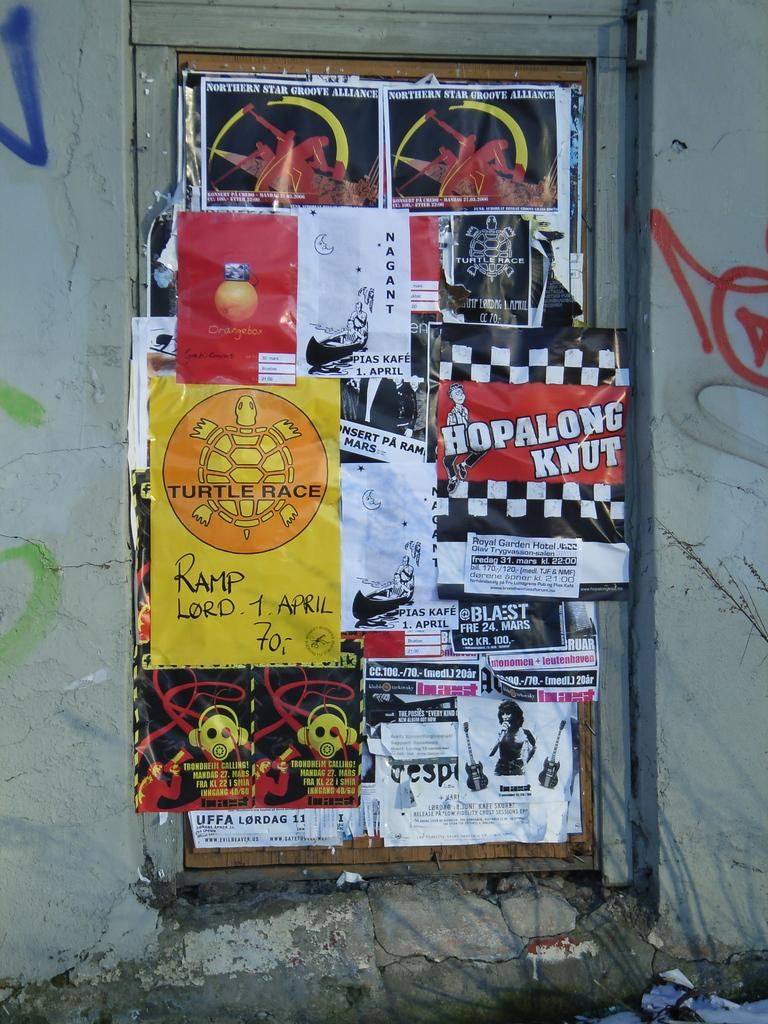Provide a one-sentence caption for the provided image. wall plaster with posters for such things as northern star groove alliance, hopalong knut, and turtle race. 